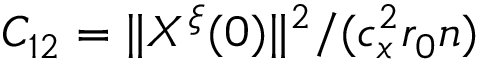Convert formula to latex. <formula><loc_0><loc_0><loc_500><loc_500>C _ { 1 2 } = \| X ^ { \xi } ( 0 ) \| ^ { 2 } / ( c _ { x } ^ { 2 } r _ { 0 } n )</formula> 